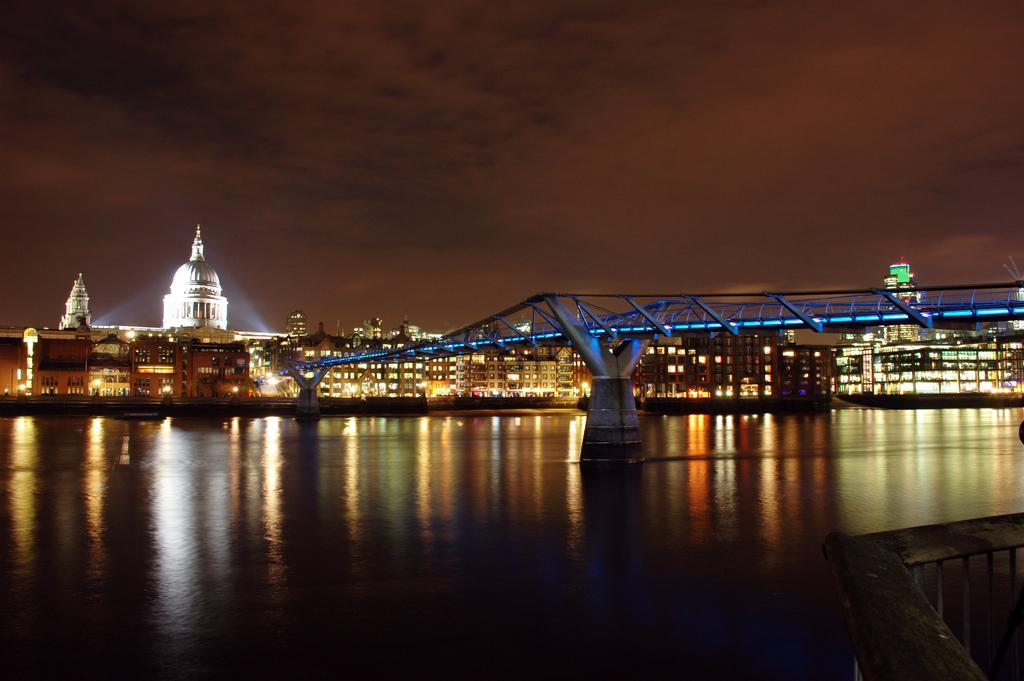What type of structures can be seen in the image? There are buildings in the image. What architectural feature is present over water in the image? There is a bridge over water in the image. What type of barrier is present in the image? There is a fence in the image. What can be seen in the sky in the image? There are clouds visible in the sky in the image. What type of cake is being served by the giants in the image? There are no giants or cake present in the image. What is the zinc content of the bridge in the image? There is no information about the zinc content of the bridge in the image. 